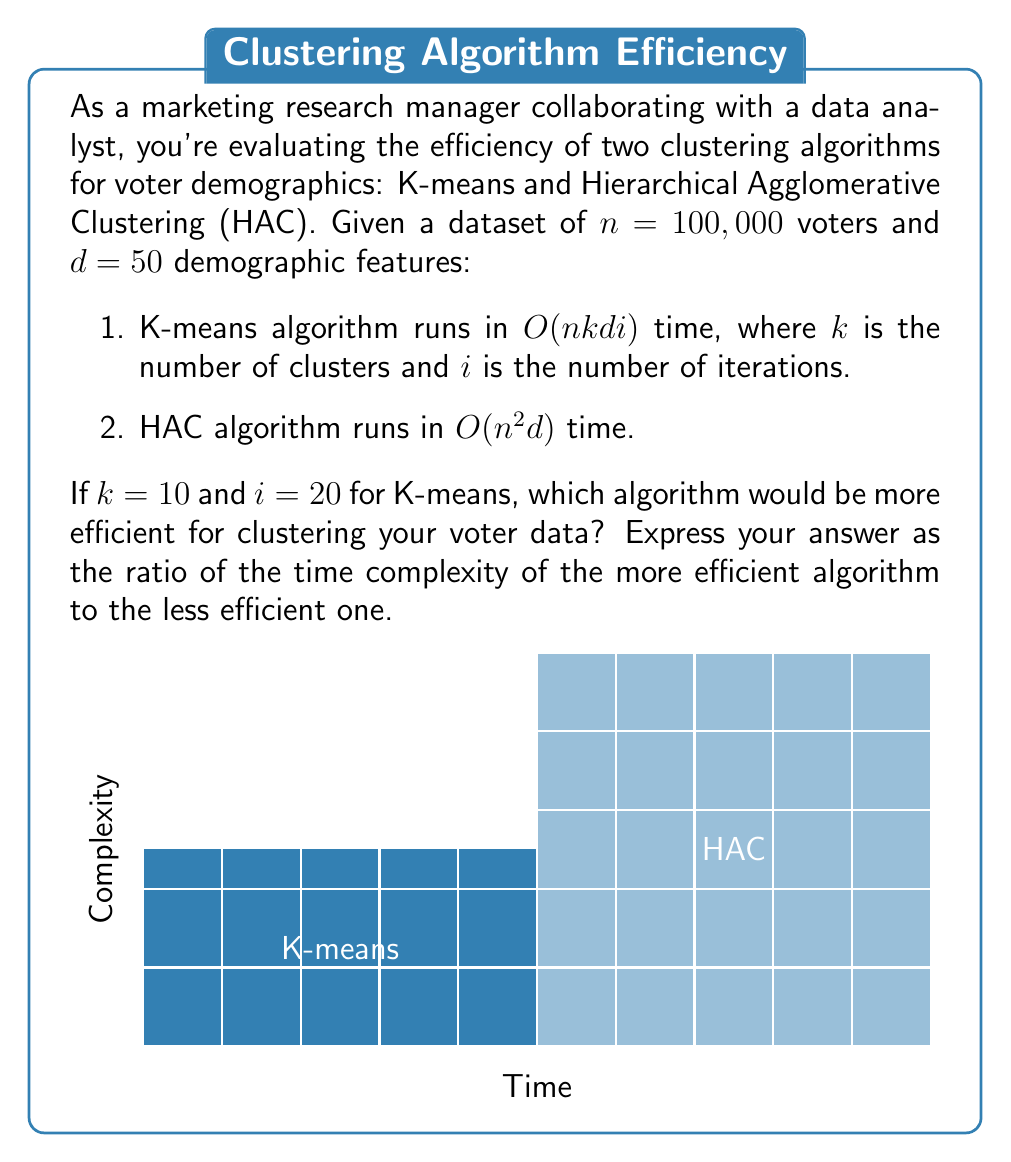Teach me how to tackle this problem. Let's approach this step-by-step:

1) First, let's calculate the time complexity for K-means:
   $O(nkdi) = O(100,000 \times 10 \times 50 \times 20) = O(10^8)$

2) Now, let's calculate the time complexity for HAC:
   $O(n^2d) = O(100,000^2 \times 50) = O(5 \times 10^{11})$

3) Comparing these, we can see that K-means has a lower time complexity:
   $O(10^8)$ vs $O(5 \times 10^{11})$

4) To express this as a ratio, we divide the time complexity of K-means by HAC:

   $$\frac{O(10^8)}{O(5 \times 10^{11})} = \frac{1}{5000}$$

5) This means K-means is 5000 times more efficient than HAC for this specific scenario.

Therefore, K-means would be the more efficient algorithm for clustering your voter data.
Answer: $\frac{1}{5000}$ 